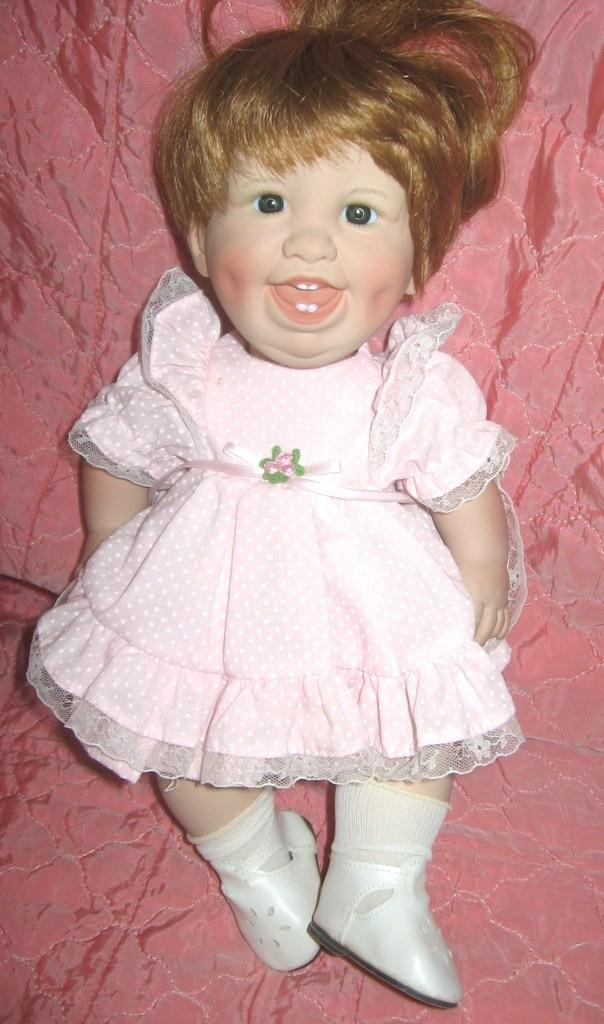What type of toy is in the image? There is a pink toy in the image. What does the toy resemble? The toy resembles a baby. Where is the toy located in the image? The toy is placed on a bed. What type of rabbit activity can be seen in the image? There is no rabbit or any rabbit activity present in the image. 